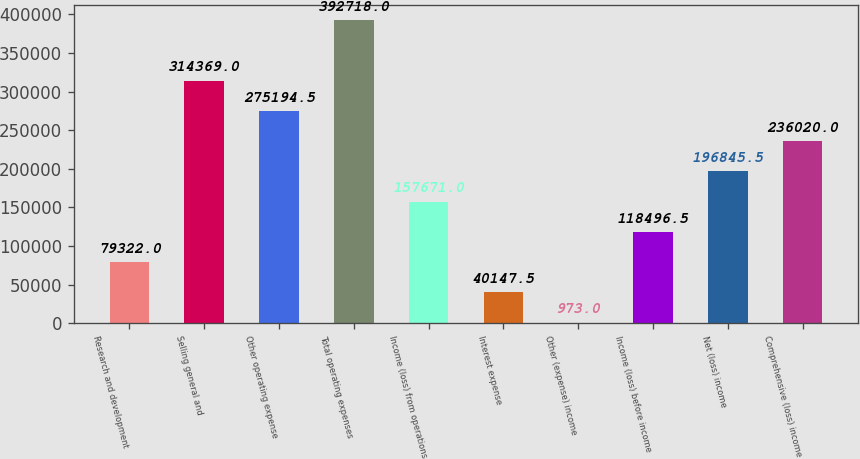Convert chart. <chart><loc_0><loc_0><loc_500><loc_500><bar_chart><fcel>Research and development<fcel>Selling general and<fcel>Other operating expense<fcel>Total operating expenses<fcel>Income (loss) from operations<fcel>Interest expense<fcel>Other (expense) income<fcel>Income (loss) before income<fcel>Net (loss) income<fcel>Comprehensive (loss) income<nl><fcel>79322<fcel>314369<fcel>275194<fcel>392718<fcel>157671<fcel>40147.5<fcel>973<fcel>118496<fcel>196846<fcel>236020<nl></chart> 